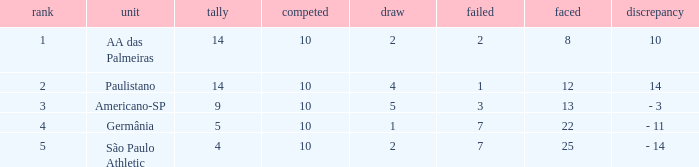What team has an against more than 8, lost of 7, and the position is 5? São Paulo Athletic. 